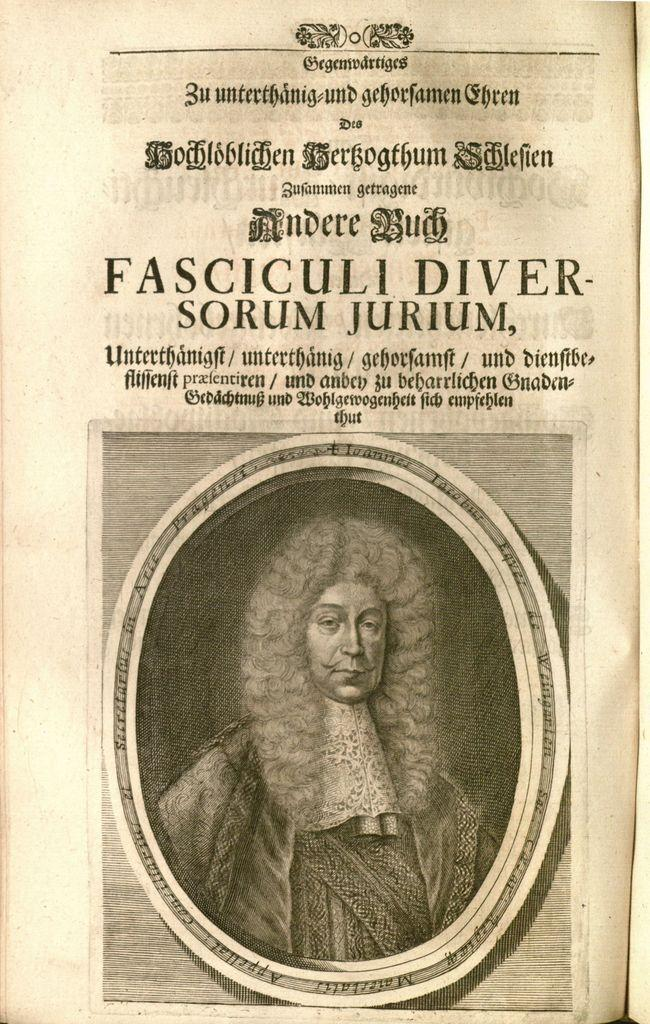What is the main subject of the image? There is a depiction of a person in the image. What else can be seen in the image besides the person? There is something written in the image. What type of coach is present in the image? There is no coach present in the image; it only features a depiction of a person and something written. How are the scissors being used in the image? There are no scissors present in the image. 